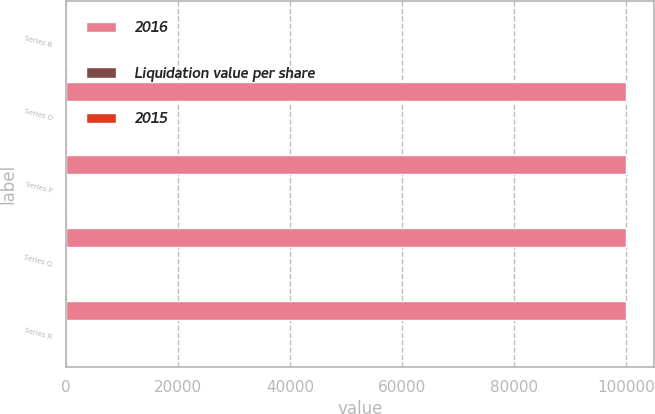Convert chart. <chart><loc_0><loc_0><loc_500><loc_500><stacked_bar_chart><ecel><fcel>Series B<fcel>Series O<fcel>Series P<fcel>Series Q<fcel>Series R<nl><fcel>2016<fcel>40<fcel>100000<fcel>100000<fcel>100000<fcel>100000<nl><fcel>Liquidation value per share<fcel>1<fcel>10<fcel>15<fcel>5<fcel>5<nl><fcel>2015<fcel>1<fcel>10<fcel>15<fcel>5<fcel>5<nl></chart> 